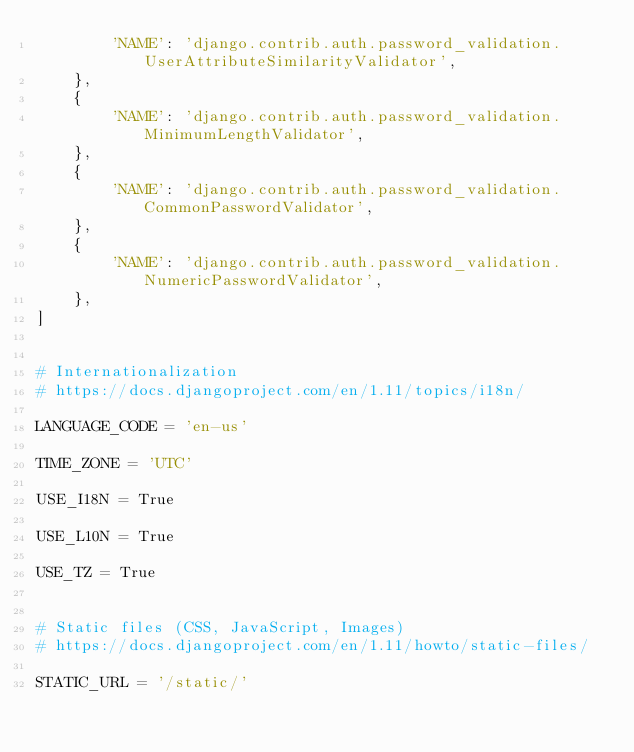Convert code to text. <code><loc_0><loc_0><loc_500><loc_500><_Python_>        'NAME': 'django.contrib.auth.password_validation.UserAttributeSimilarityValidator',
    },
    {
        'NAME': 'django.contrib.auth.password_validation.MinimumLengthValidator',
    },
    {
        'NAME': 'django.contrib.auth.password_validation.CommonPasswordValidator',
    },
    {
        'NAME': 'django.contrib.auth.password_validation.NumericPasswordValidator',
    },
]


# Internationalization
# https://docs.djangoproject.com/en/1.11/topics/i18n/

LANGUAGE_CODE = 'en-us'

TIME_ZONE = 'UTC'

USE_I18N = True

USE_L10N = True

USE_TZ = True


# Static files (CSS, JavaScript, Images)
# https://docs.djangoproject.com/en/1.11/howto/static-files/

STATIC_URL = '/static/'
</code> 